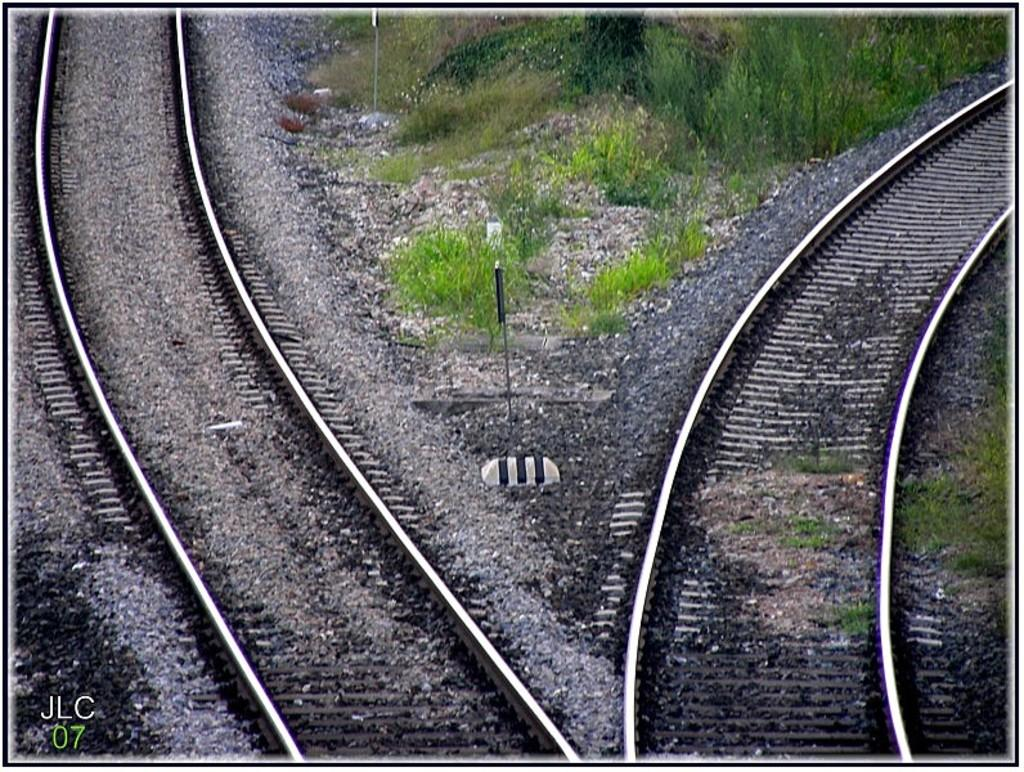What can be seen running through the center of the image? There are tracks in the image. What is located in the center of the image, along with the tracks? There are poles and grass present in the center of the image. What type of vegetation can be seen in the center of the image? There are plants in the center of the image. What is visible at the bottom of the image? There are stones at the bottom of the image. What type of cloth is draped over the spark in the image? There is no spark or cloth present in the image. Is there a camp visible in the image? There is no camp present in the image. 